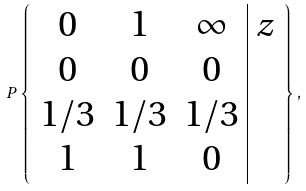Convert formula to latex. <formula><loc_0><loc_0><loc_500><loc_500>P \left \{ \begin{array} { c c c | c } 0 & 1 & \infty & z \\ 0 & 0 & 0 & \\ 1 / 3 & 1 / 3 & 1 / 3 & \\ 1 & 1 & 0 & \\ \end{array} \right \} ,</formula> 